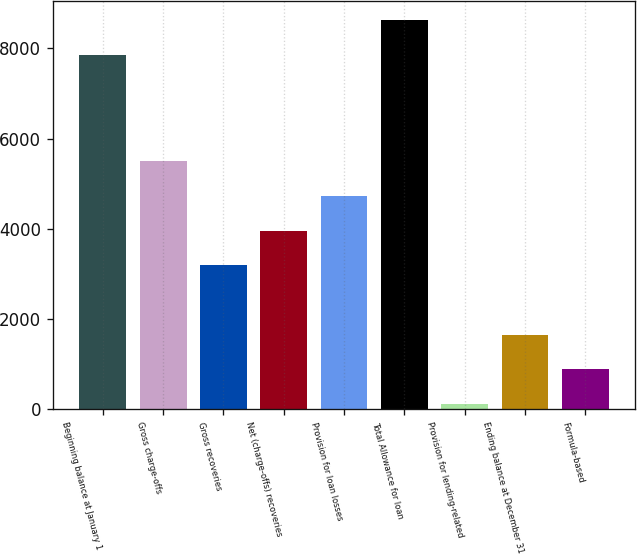Convert chart to OTSL. <chart><loc_0><loc_0><loc_500><loc_500><bar_chart><fcel>Beginning balance at January 1<fcel>Gross charge-offs<fcel>Gross recoveries<fcel>Net (charge-offs) recoveries<fcel>Provision for loan losses<fcel>Total Allowance for loan<fcel>Provision for lending-related<fcel>Ending balance at December 31<fcel>Formula-based<nl><fcel>7858.6<fcel>5497.2<fcel>3191.4<fcel>3960<fcel>4728.6<fcel>8627.2<fcel>117<fcel>1654.2<fcel>885.6<nl></chart> 